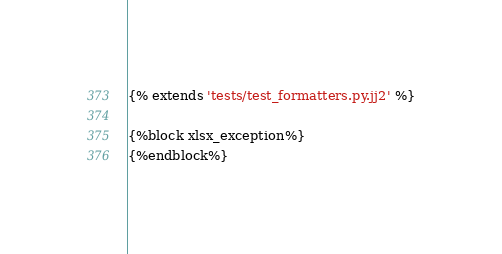<code> <loc_0><loc_0><loc_500><loc_500><_Python_>{% extends 'tests/test_formatters.py.jj2' %}

{%block xlsx_exception%}
{%endblock%}</code> 